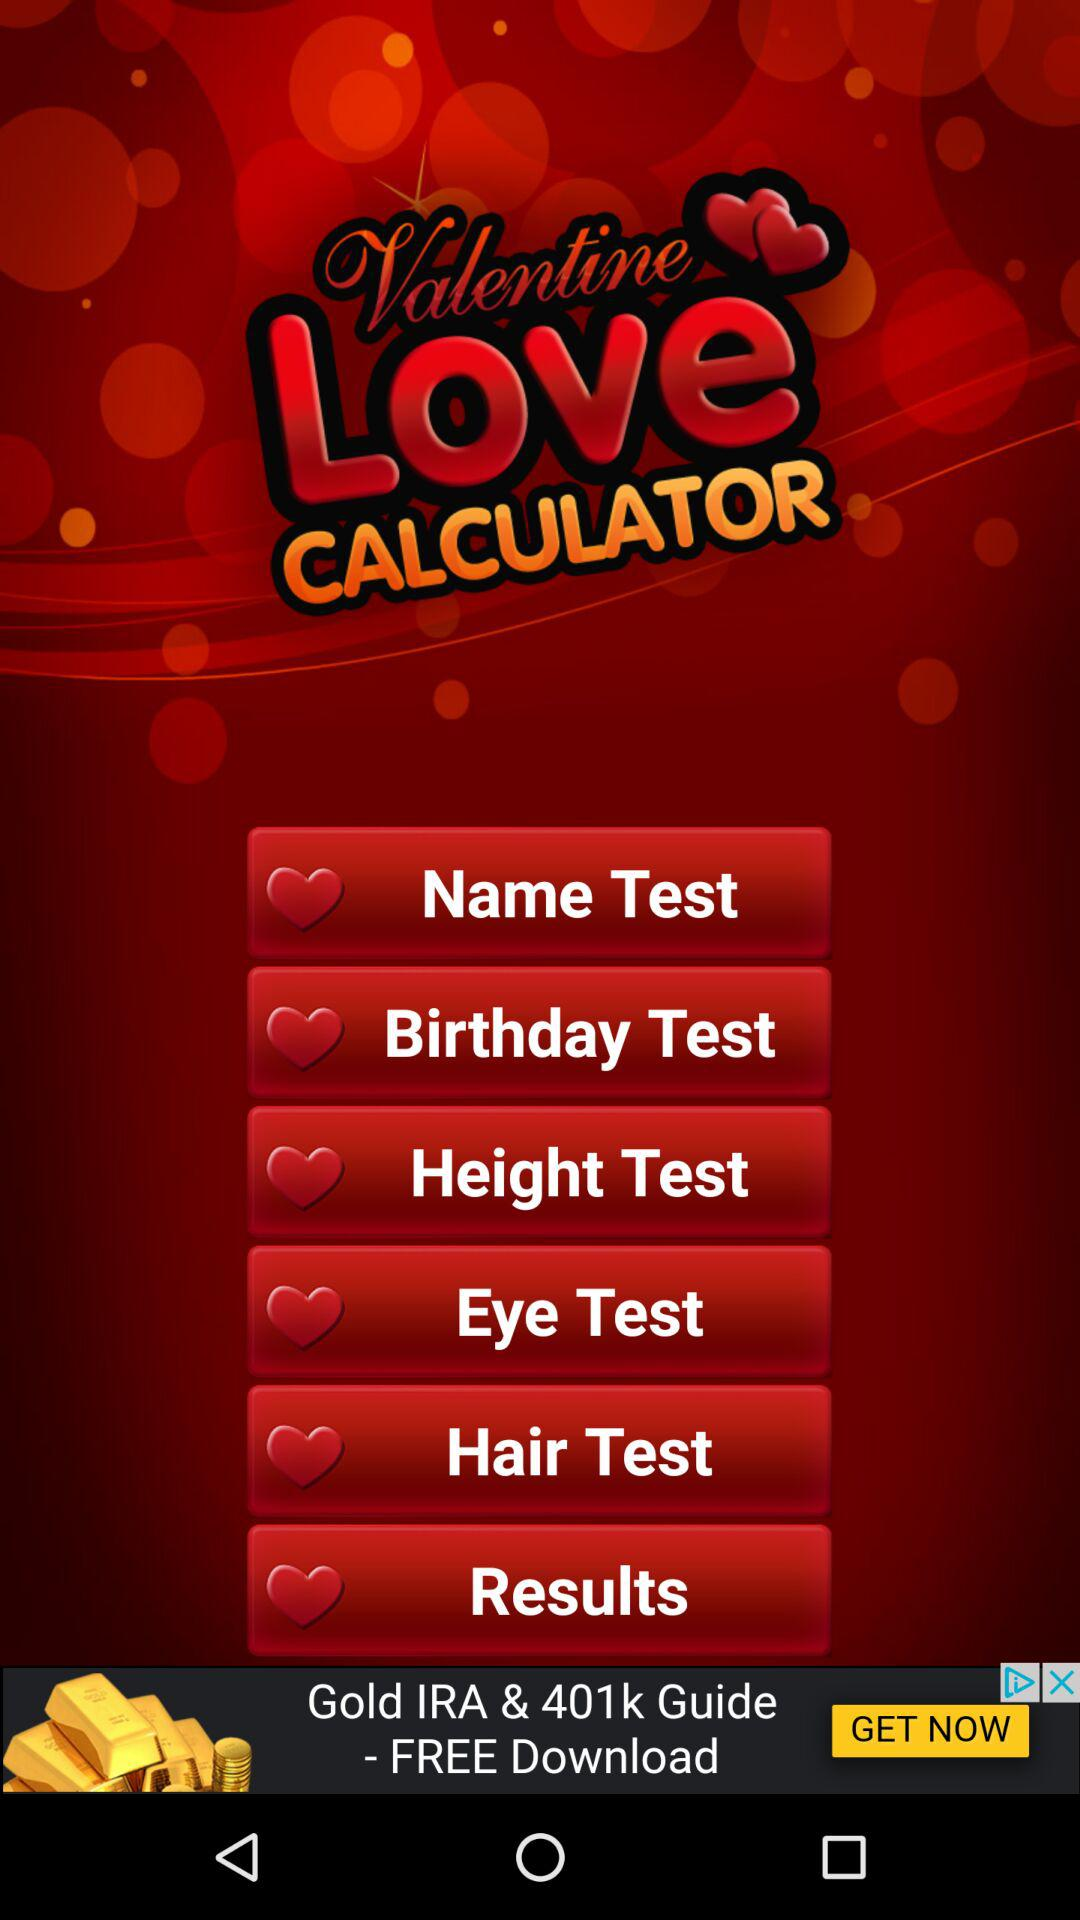What are the different tests available? The different available tests are "Name", "Birthday", "Height", "Eye" and "Hair". 